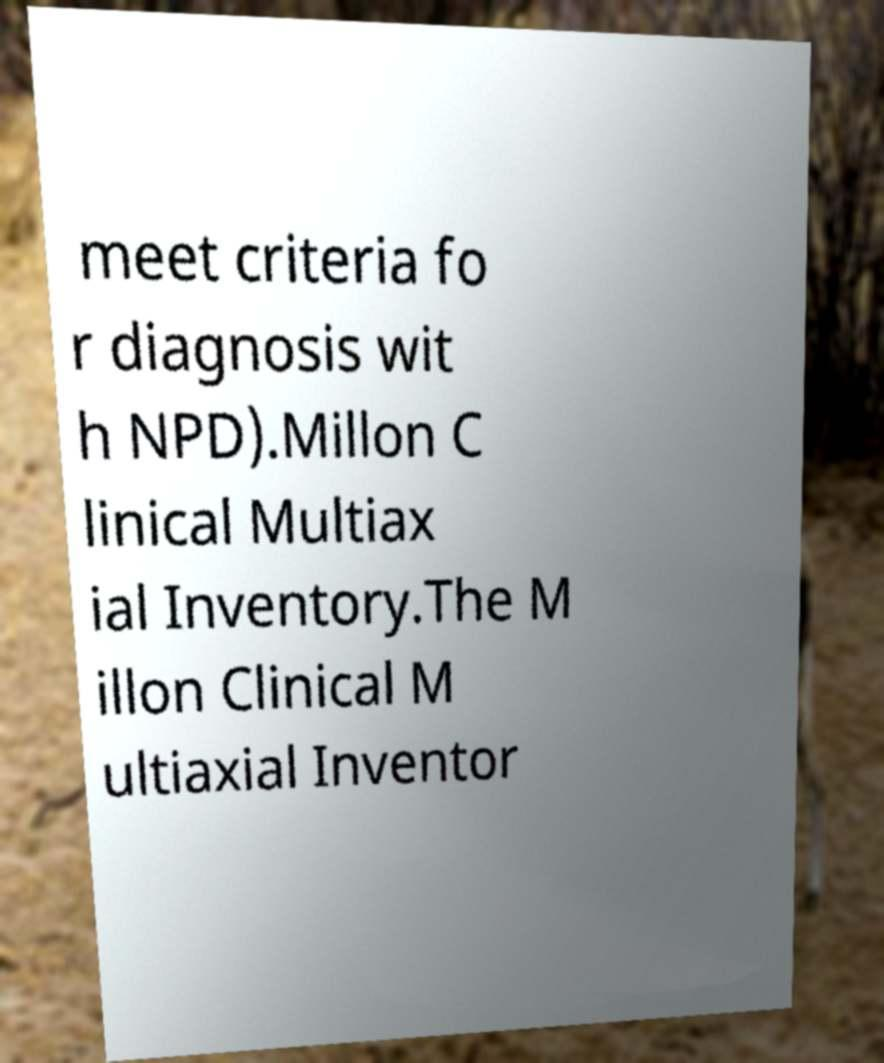Could you extract and type out the text from this image? meet criteria fo r diagnosis wit h NPD).Millon C linical Multiax ial Inventory.The M illon Clinical M ultiaxial Inventor 